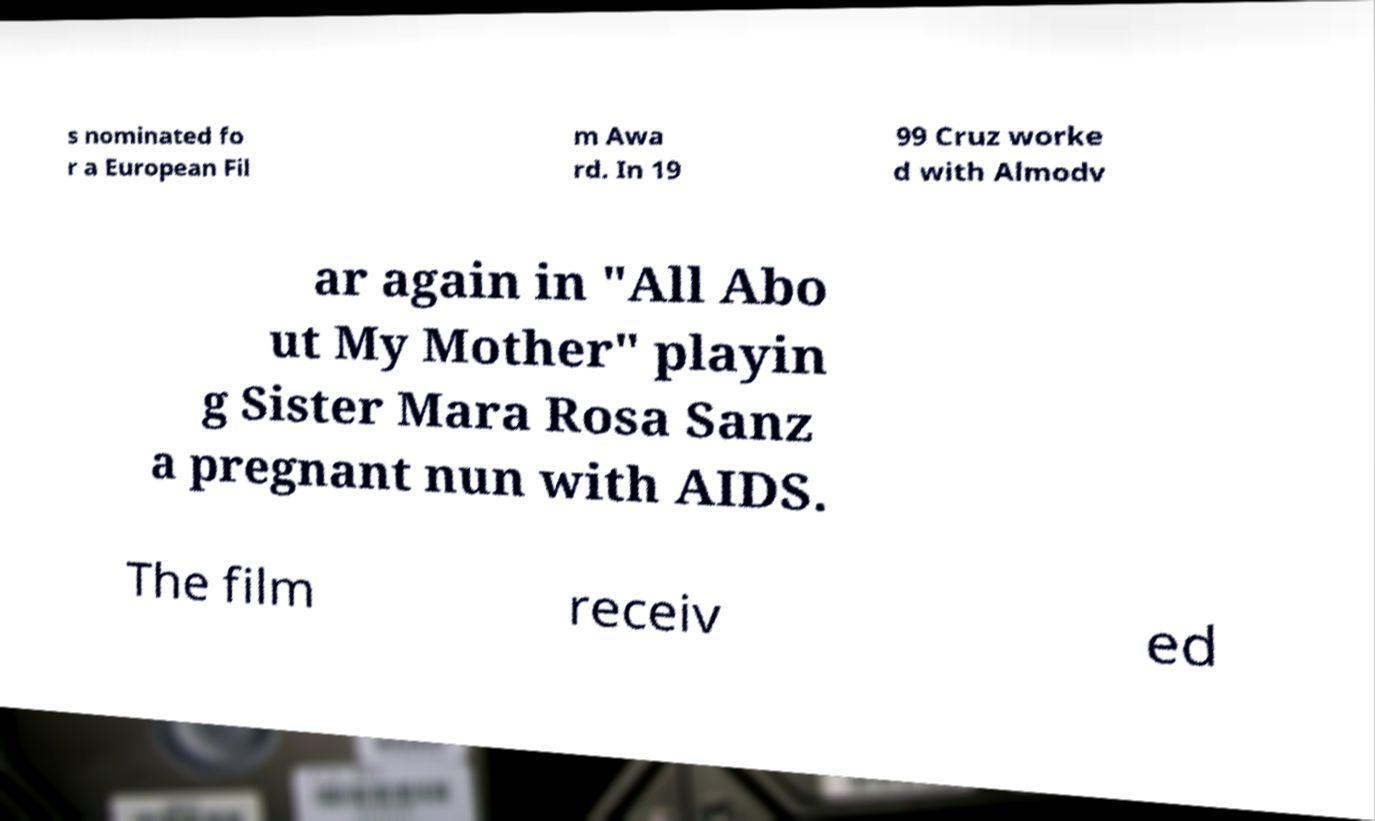Could you extract and type out the text from this image? s nominated fo r a European Fil m Awa rd. In 19 99 Cruz worke d with Almodv ar again in "All Abo ut My Mother" playin g Sister Mara Rosa Sanz a pregnant nun with AIDS. The film receiv ed 